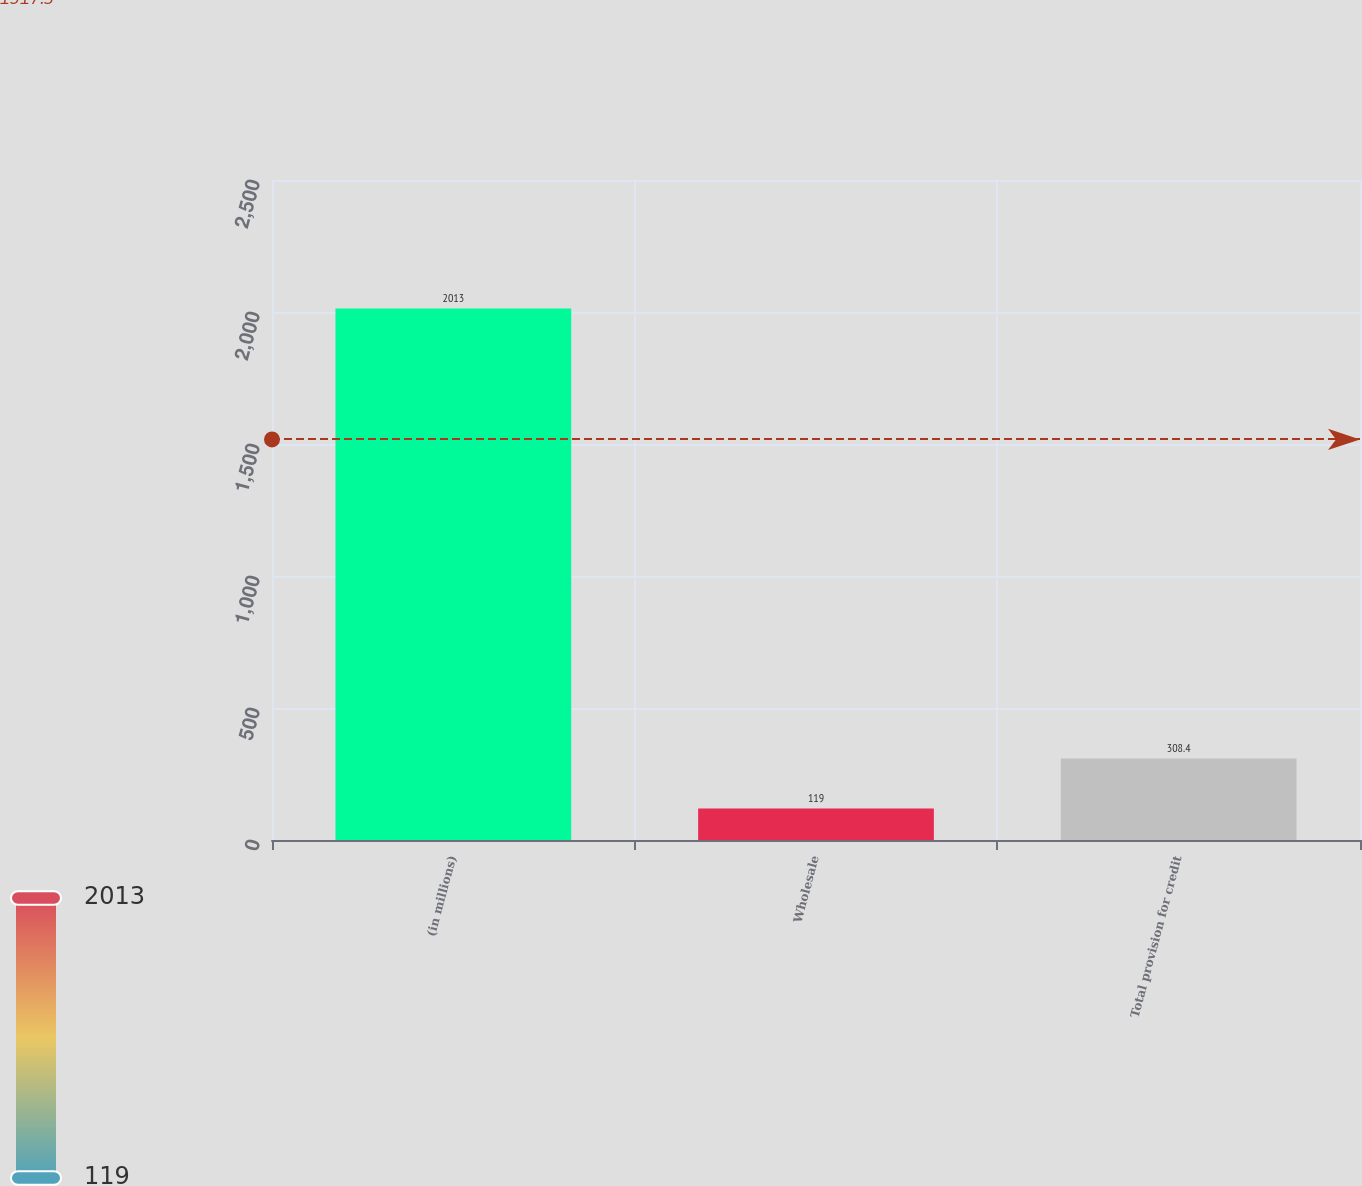Convert chart to OTSL. <chart><loc_0><loc_0><loc_500><loc_500><bar_chart><fcel>(in millions)<fcel>Wholesale<fcel>Total provision for credit<nl><fcel>2013<fcel>119<fcel>308.4<nl></chart> 